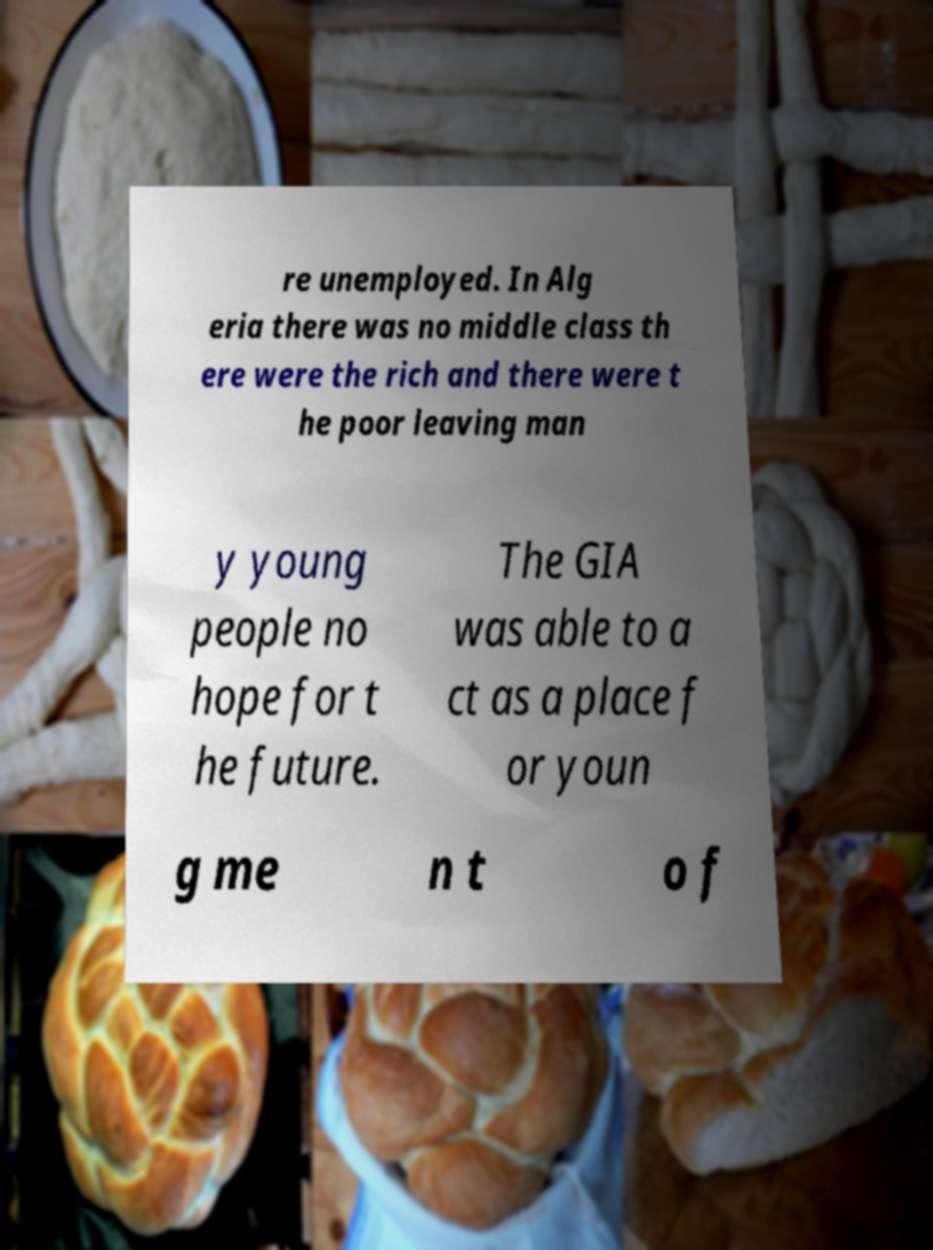I need the written content from this picture converted into text. Can you do that? re unemployed. In Alg eria there was no middle class th ere were the rich and there were t he poor leaving man y young people no hope for t he future. The GIA was able to a ct as a place f or youn g me n t o f 